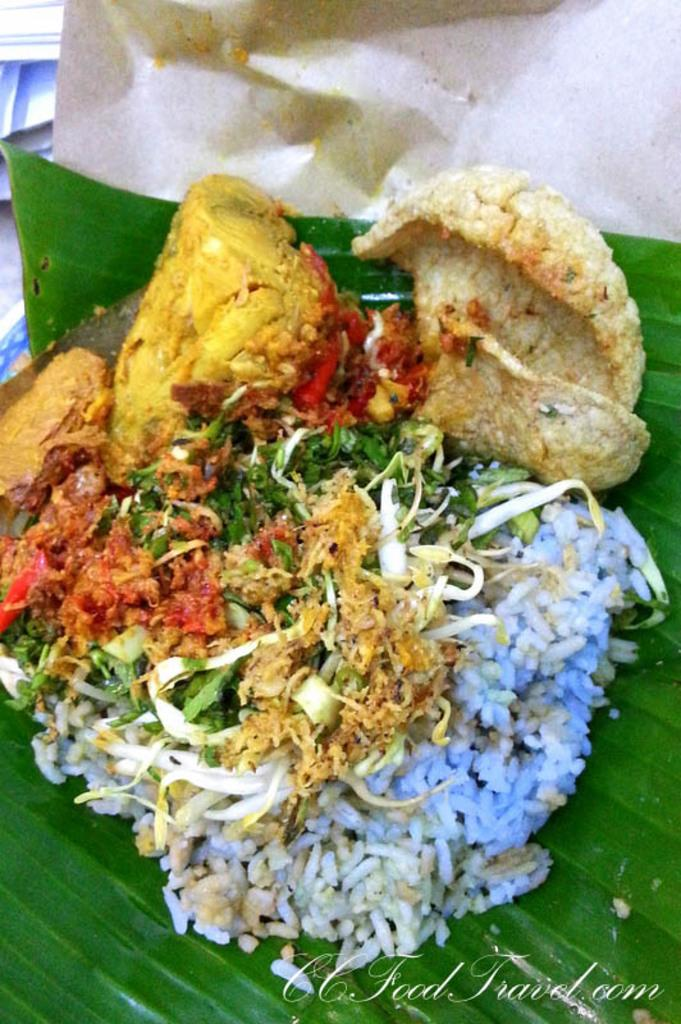What is the main object in the image? There is a banana leaf in the image. What is on the banana leaf? The banana leaf has rice on it, and there are green leaves on it as well. What else can be seen on the banana leaf? There is food stuff on the banana leaf. How is the banana leaf placed? The banana leaf is on a piece of paper. How many cacti can be seen in the image? There are no cacti present in the image. Is the environment in the image quiet or noisy? The image does not provide any information about the noise level in the environment. 